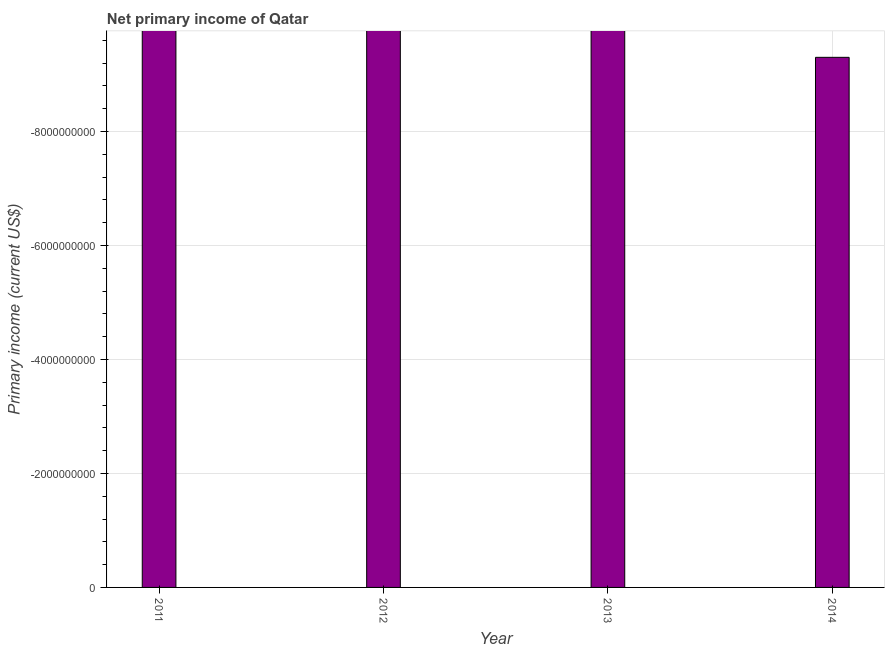What is the title of the graph?
Offer a terse response. Net primary income of Qatar. What is the label or title of the X-axis?
Keep it short and to the point. Year. What is the label or title of the Y-axis?
Provide a short and direct response. Primary income (current US$). Across all years, what is the minimum amount of primary income?
Your response must be concise. 0. What is the sum of the amount of primary income?
Keep it short and to the point. 0. What is the median amount of primary income?
Keep it short and to the point. 0. In how many years, is the amount of primary income greater than -8800000000 US$?
Offer a very short reply. 0. How many bars are there?
Provide a short and direct response. 0. Are all the bars in the graph horizontal?
Provide a succinct answer. No. How many years are there in the graph?
Your answer should be compact. 4. What is the Primary income (current US$) in 2011?
Ensure brevity in your answer.  0. 